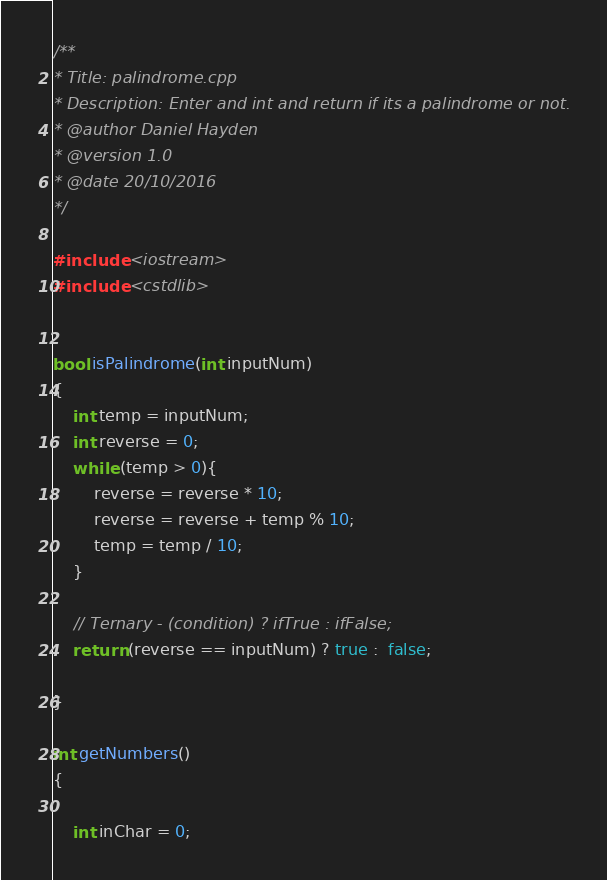<code> <loc_0><loc_0><loc_500><loc_500><_C++_>/**
* Title: palindrome.cpp
* Description: Enter and int and return if its a palindrome or not.
* @author Daniel Hayden
* @version 1.0
* @date 20/10/2016
*/

#include <iostream>
#include <cstdlib>


bool isPalindrome(int inputNum)
{
	int temp = inputNum;
	int reverse = 0;
	while (temp > 0){
		reverse = reverse * 10;
		reverse = reverse + temp % 10;
		temp = temp / 10;
	}

	// Ternary - (condition) ? ifTrue : ifFalse; 
	return (reverse == inputNum) ? true :  false;

}

int getNumbers()
{

	int inChar = 0;</code> 